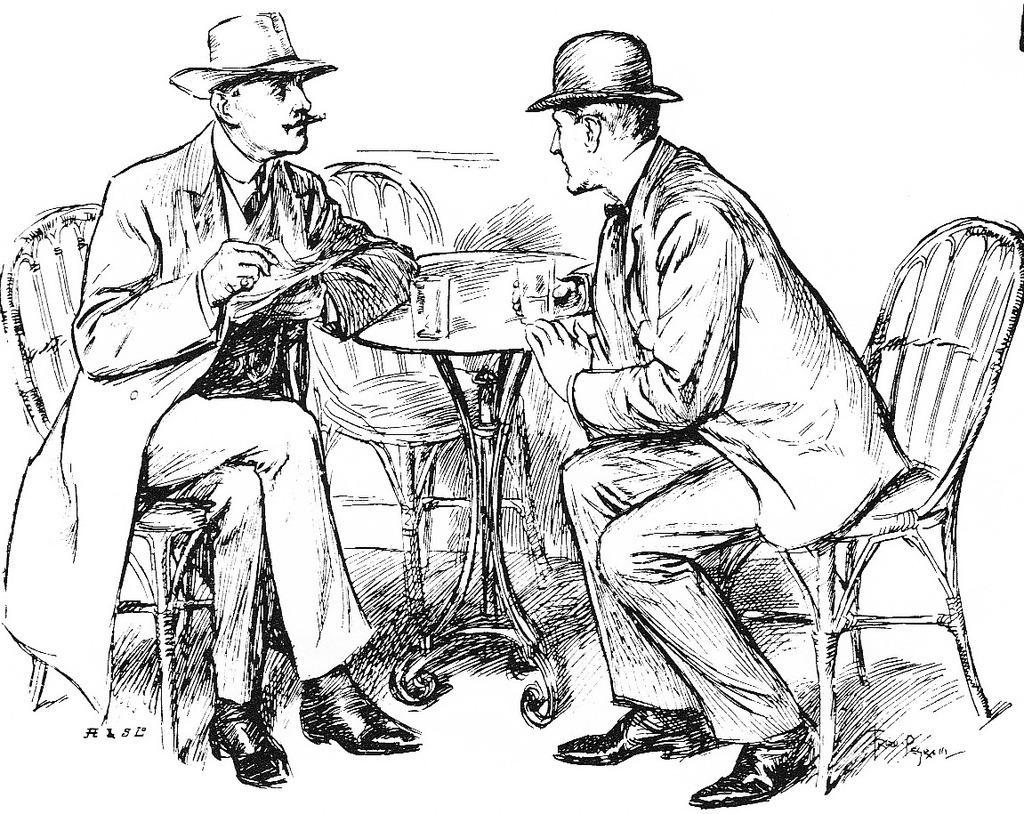How would you summarize this image in a sentence or two? In this picture there is a pencil sketch of two men sitting beside the table. Both of them are wearing jackets and hats. On the table there are two glasses. 